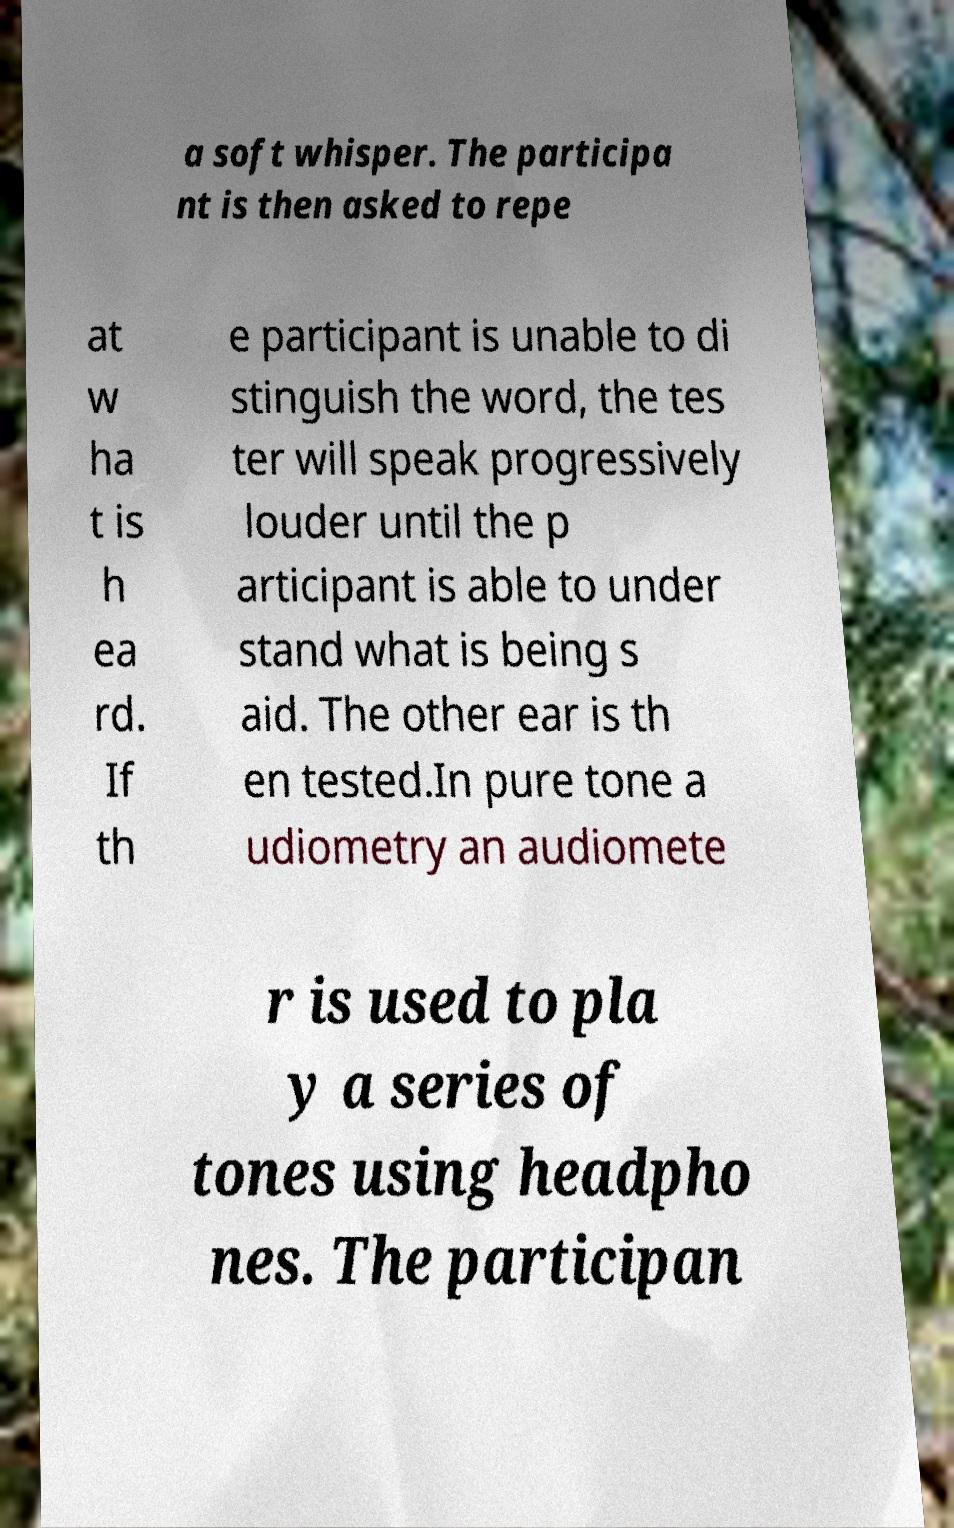Could you assist in decoding the text presented in this image and type it out clearly? a soft whisper. The participa nt is then asked to repe at w ha t is h ea rd. If th e participant is unable to di stinguish the word, the tes ter will speak progressively louder until the p articipant is able to under stand what is being s aid. The other ear is th en tested.In pure tone a udiometry an audiomete r is used to pla y a series of tones using headpho nes. The participan 